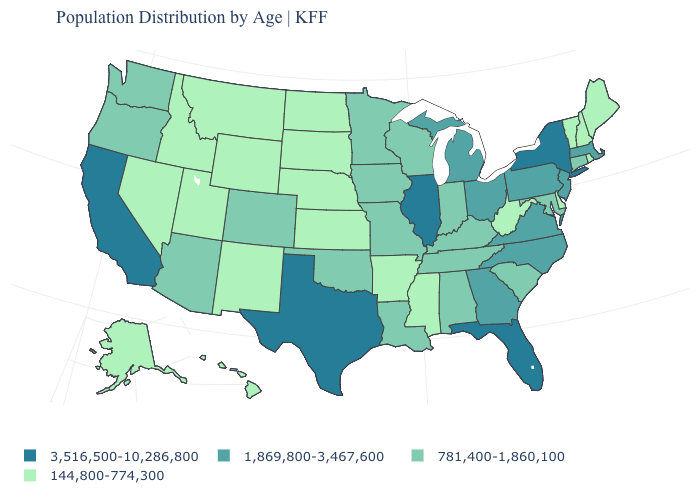Is the legend a continuous bar?
Concise answer only. No. What is the value of Indiana?
Write a very short answer. 781,400-1,860,100. What is the value of Maine?
Answer briefly. 144,800-774,300. What is the highest value in the USA?
Keep it brief. 3,516,500-10,286,800. What is the value of South Dakota?
Write a very short answer. 144,800-774,300. What is the highest value in the South ?
Give a very brief answer. 3,516,500-10,286,800. What is the value of Arkansas?
Short answer required. 144,800-774,300. Does Connecticut have a lower value than Kansas?
Short answer required. No. Among the states that border California , which have the lowest value?
Give a very brief answer. Nevada. What is the value of Louisiana?
Quick response, please. 781,400-1,860,100. Name the states that have a value in the range 3,516,500-10,286,800?
Be succinct. California, Florida, Illinois, New York, Texas. Name the states that have a value in the range 1,869,800-3,467,600?
Concise answer only. Georgia, Massachusetts, Michigan, New Jersey, North Carolina, Ohio, Pennsylvania, Virginia. Does Tennessee have the same value as New York?
Answer briefly. No. Does Utah have the lowest value in the West?
Answer briefly. Yes. Name the states that have a value in the range 1,869,800-3,467,600?
Be succinct. Georgia, Massachusetts, Michigan, New Jersey, North Carolina, Ohio, Pennsylvania, Virginia. 